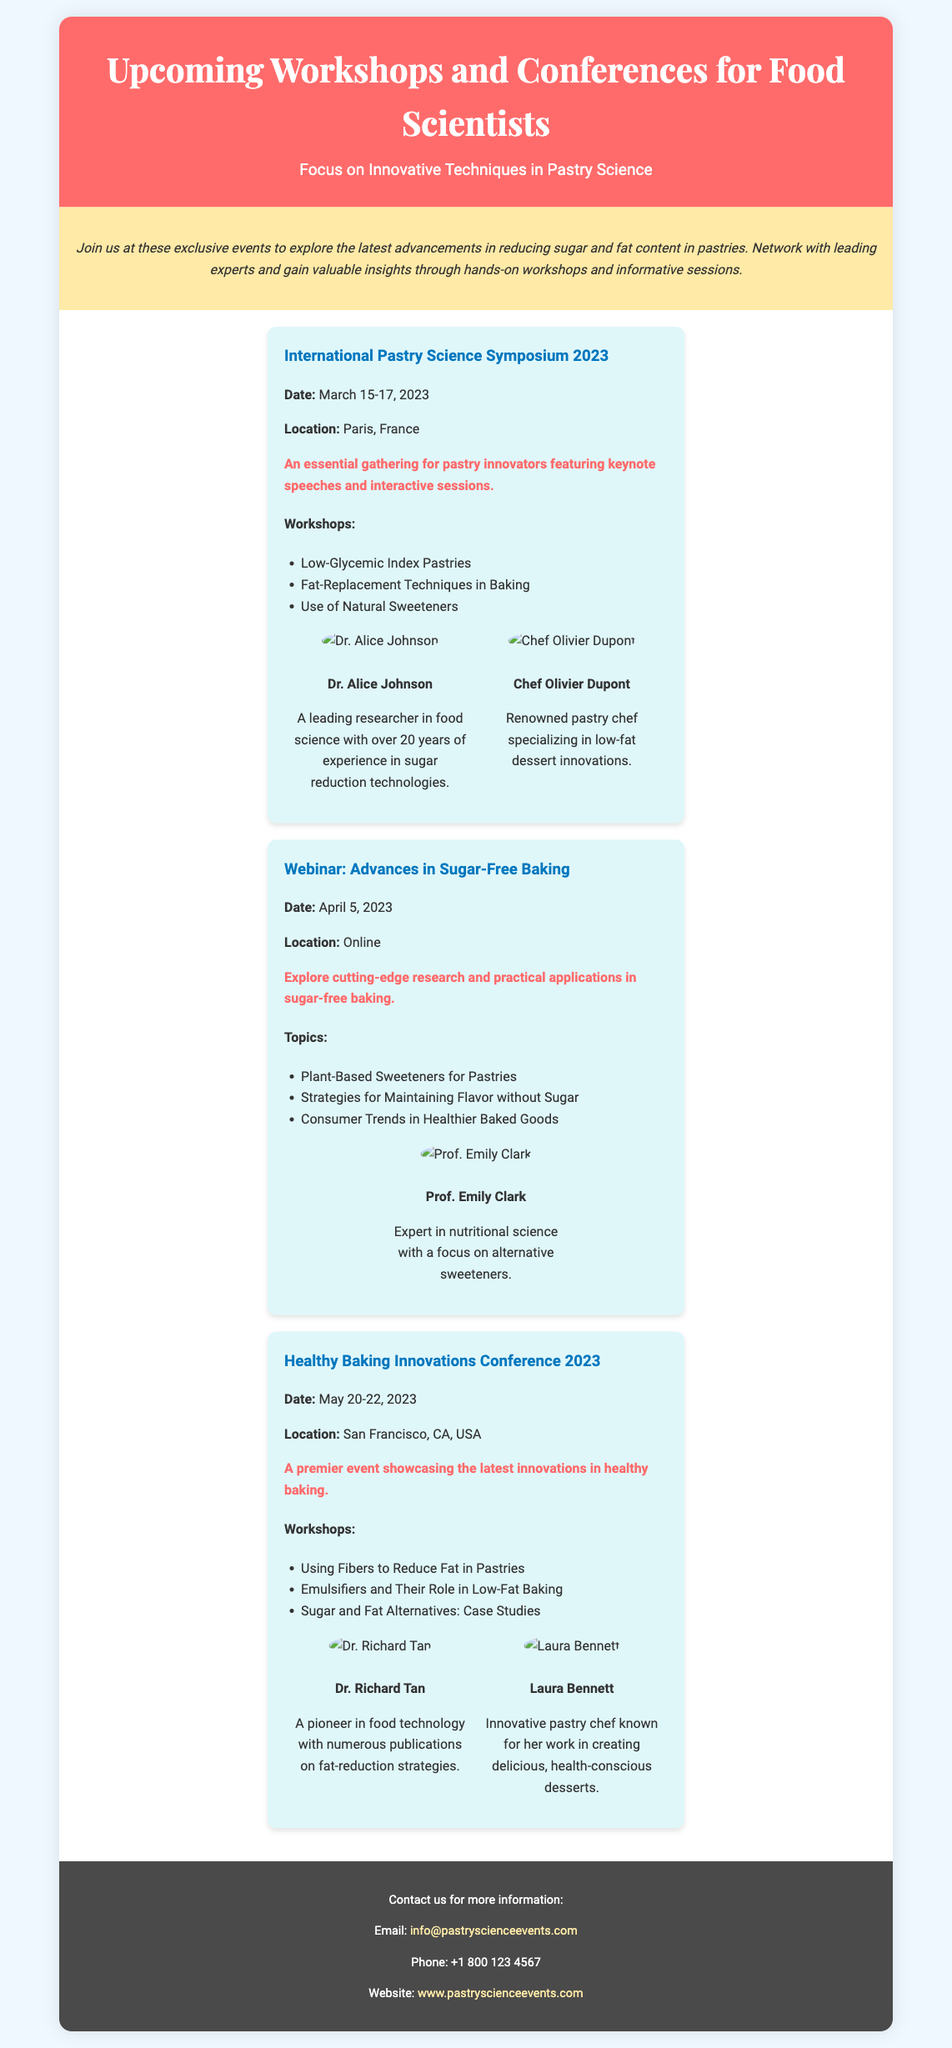What is the date of the International Pastry Science Symposium 2023? The date of the symposium is specified in the document as March 15-17, 2023.
Answer: March 15-17, 2023 Who is a speaker at the Healthy Baking Innovations Conference 2023? The document lists Dr. Richard Tan and Laura Bennett as speakers at the conference.
Answer: Dr. Richard Tan What workshop focuses on reducing fat in pastries? The document mentions "Using Fibers to Reduce Fat in Pastries" as one of the workshops.
Answer: Using Fibers to Reduce Fat in Pastries What is the location of the Webinar on Advances in Sugar-Free Baking? The location is indicated as "Online" in the event details.
Answer: Online How many workshops are listed for the International Pastry Science Symposium 2023? The document lists three workshops under the symposium's details.
Answer: Three What is the highlight of the Webinar: Advances in Sugar-Free Baking? The highlight sentence that describes the webinar is mentioned in the document.
Answer: Explore cutting-edge research and practical applications in sugar-free baking What is the main theme of the upcoming events according to the introduction? The introduction clearly states the theme of the events is focused on reducing sugar and fat content in pastries.
Answer: Reducing sugar and fat content in pastries How can attendees contact the organizers for more information? The document provides an email address and a phone number for contacting the organizers.
Answer: info@pastryscienceevents.com What city will host the Healthy Baking Innovations Conference 2023? The document specifies that the conference will be held in San Francisco, CA, USA.
Answer: San Francisco, CA, USA 